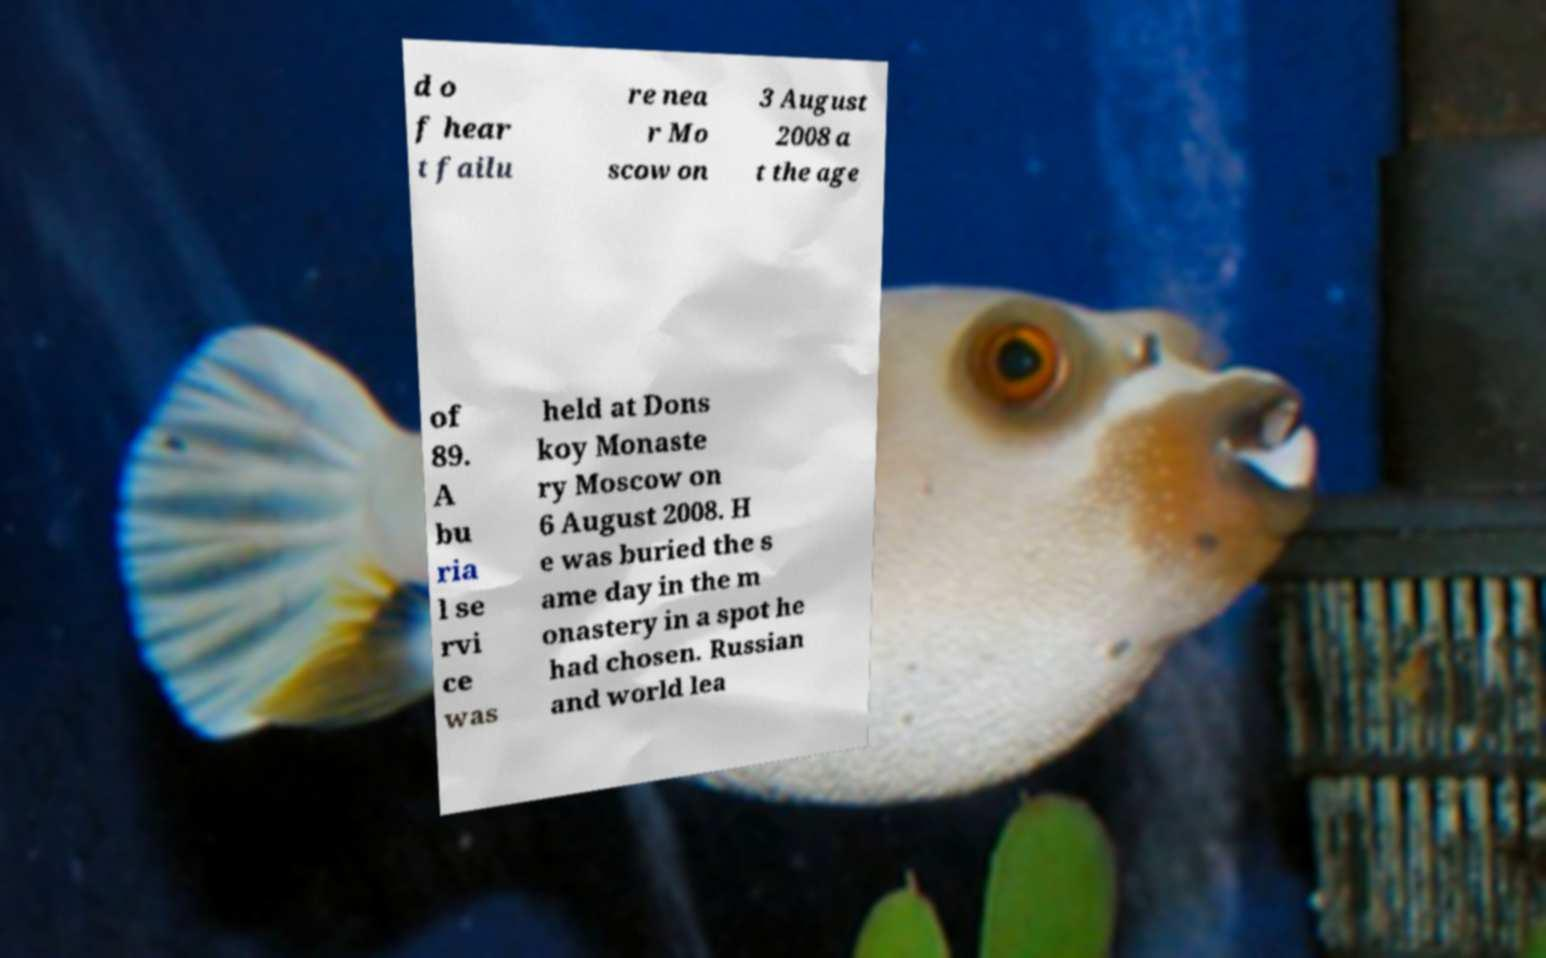Please identify and transcribe the text found in this image. d o f hear t failu re nea r Mo scow on 3 August 2008 a t the age of 89. A bu ria l se rvi ce was held at Dons koy Monaste ry Moscow on 6 August 2008. H e was buried the s ame day in the m onastery in a spot he had chosen. Russian and world lea 